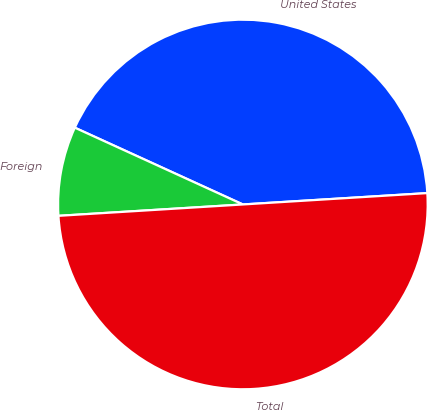Convert chart to OTSL. <chart><loc_0><loc_0><loc_500><loc_500><pie_chart><fcel>United States<fcel>Foreign<fcel>Total<nl><fcel>42.2%<fcel>7.8%<fcel>50.0%<nl></chart> 